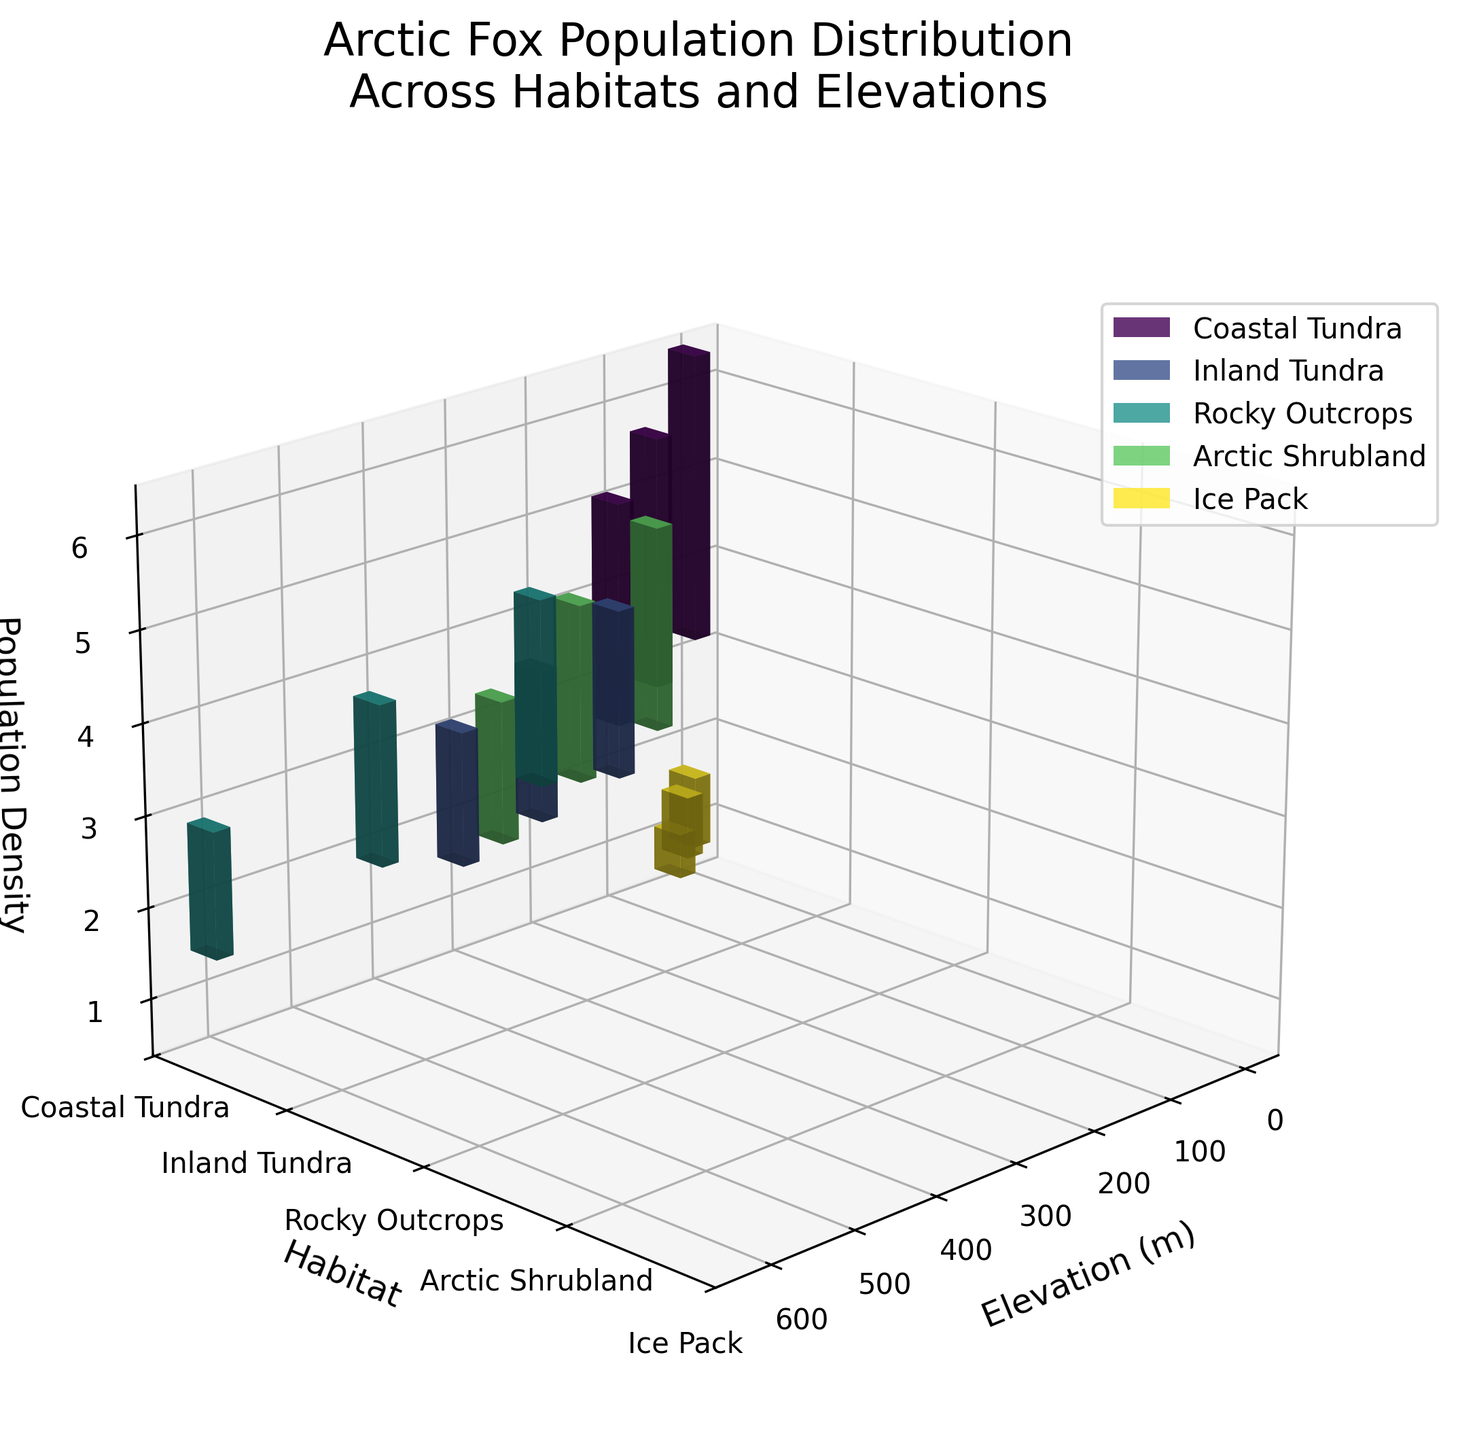What is the title of the figure? The title of the figure is written at the top of the plot in a larger font size. It typically provides the main subject of the plot. In this case, the title indicates that the figure is about Arctic fox population distribution across different habitats and elevations.
Answer: Arctic Fox Population Distribution Across Habitats and Elevations What does the x-axis represent? The x-axis is labeled 'Elevation (m)', which means it represents the elevation in meters. All the tick values along this axis are in meters.
Answer: Elevation (m) Which habitat has the highest population density of Arctic foxes at any elevation? To determine which habitat has the highest population density, we look for the tallest bar overall across all habitats and elevations. The highest bar represents a population density of 3.2 foxes/km² in the Coastal Tundra habitat at 0 meters elevation.
Answer: Coastal Tundra How does the population density of Arctic foxes in Inland Tundra compare at 100m and 300m elevation? We need to compare the heights of the bars for Inland Tundra at 100m and 300m elevation. The bar at 100m is taller than the bar at 300m (1.9 vs 1.5 foxes/km², respectively). This shows a decrease in population density with increasing elevation in this habitat.
Answer: Decreases Which habitat shows the lowest population density at 0 meters elevation? By comparing the heights of the bars at 0 meters for each habitat, the shortest bar represents Ice Pack with a population density of 0.8 foxes/km².
Answer: Ice Pack What is the color legend used for the habitats in the figure? The color legend in the figure is represented by colored rectangles associated with each habitat name, located in the upper right of the plot. The colors are assigned to distinguish between different habitats.
Answer: Colored rectangles What is the average population density of Arctic foxes across all elevations in the Coastal Tundra habitat? To find this average, sum the population densities at 0m, 50m, and 100m in Coastal Tundra: 3.2 + 2.8 + 2.5 = 8.5. Then, divide by the number of data points (3): 8.5 / 3 = 2.83 (rounded to two decimal places).
Answer: 2.83 In which habitat does population density change the most with increasing elevation? We need to examine the change in population density from the lowest to the highest elevation for each habitat. Coastal Tundra decreases from 3.2 to 2.5, Inland Tundra from 1.9 to 1.5, Rocky Outcrops from 2.1 to 1.4, Arctic Shrubland from 2.3 to 1.6, and Ice Pack from 0.8 to 0.5. The largest change is in Rocky Outcrops, decreasing by 0.7.
Answer: Rocky Outcrops Is there any habitat where the population density of Arctic foxes remains constant across different elevations? By observing the bars, we notice that in every habitat, the population density changes as elevation increases, implying there is no habitat with constant population density across elevations.
Answer: No 